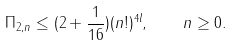Convert formula to latex. <formula><loc_0><loc_0><loc_500><loc_500>\Pi _ { 2 , n } \leq ( 2 + \frac { 1 } { 1 6 } ) ( n ! ) ^ { 4 l } , \quad n \geq 0 .</formula> 